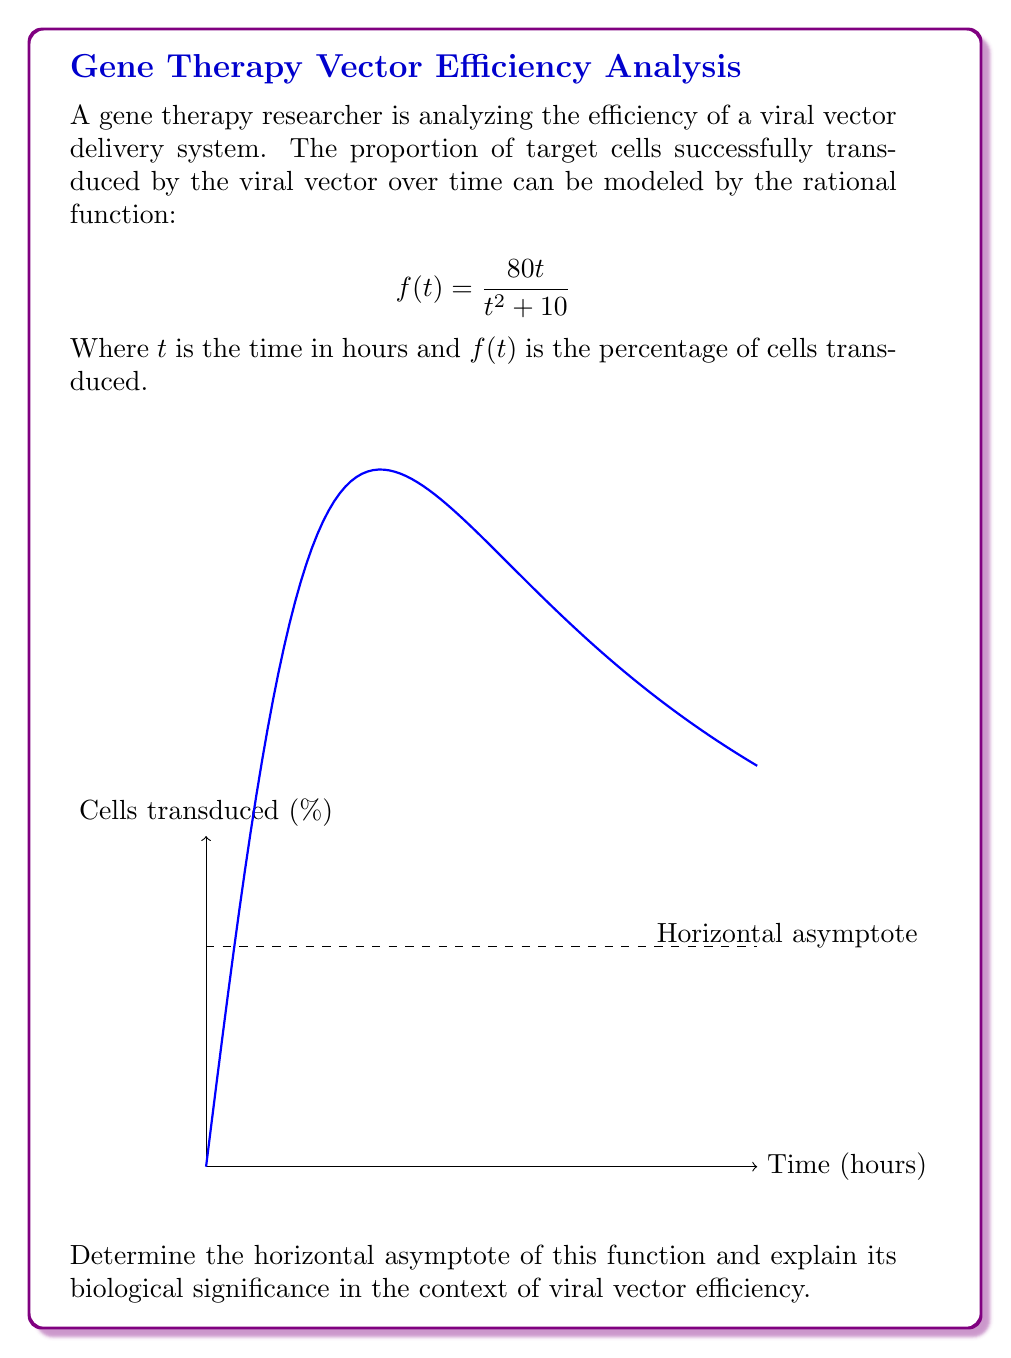Give your solution to this math problem. To find the horizontal asymptote, we need to analyze the behavior of the function as $t$ approaches infinity. Let's follow these steps:

1) For a rational function $\frac{P(t)}{Q(t)}$, the horizontal asymptote is determined by comparing the degrees of the numerator and denominator.

2) In this case, $f(t) = \frac{80t}{t^2 + 10}$

3) The degree of the numerator is 1, and the degree of the denominator is 2.

4) When the degree of the denominator is greater than the degree of the numerator, the horizontal asymptote is y = 0.

5) However, we can also calculate this explicitly:

   $$\lim_{t \to \infty} f(t) = \lim_{t \to \infty} \frac{80t}{t^2 + 10} = \lim_{t \to \infty} \frac{80}{t + \frac{10}{t}} = 0$$

6) Therefore, the horizontal asymptote is y = 0.

Biological significance:
The horizontal asymptote represents the theoretical maximum efficiency of the viral vector delivery system as time approaches infinity. In this case, the asymptote being 0 suggests that the efficiency of the system decreases over time, approaching 0% as time goes to infinity. This could indicate factors such as:

- The viral vectors becoming less effective over time
- The target cells developing resistance to transduction
- Degradation of the viral vectors in the cellular environment

This information is crucial for a gene therapy researcher to understand the long-term behavior and limitations of the viral vector delivery system.
Answer: The horizontal asymptote is y = 0, indicating decreasing long-term efficiency of the viral vector system. 